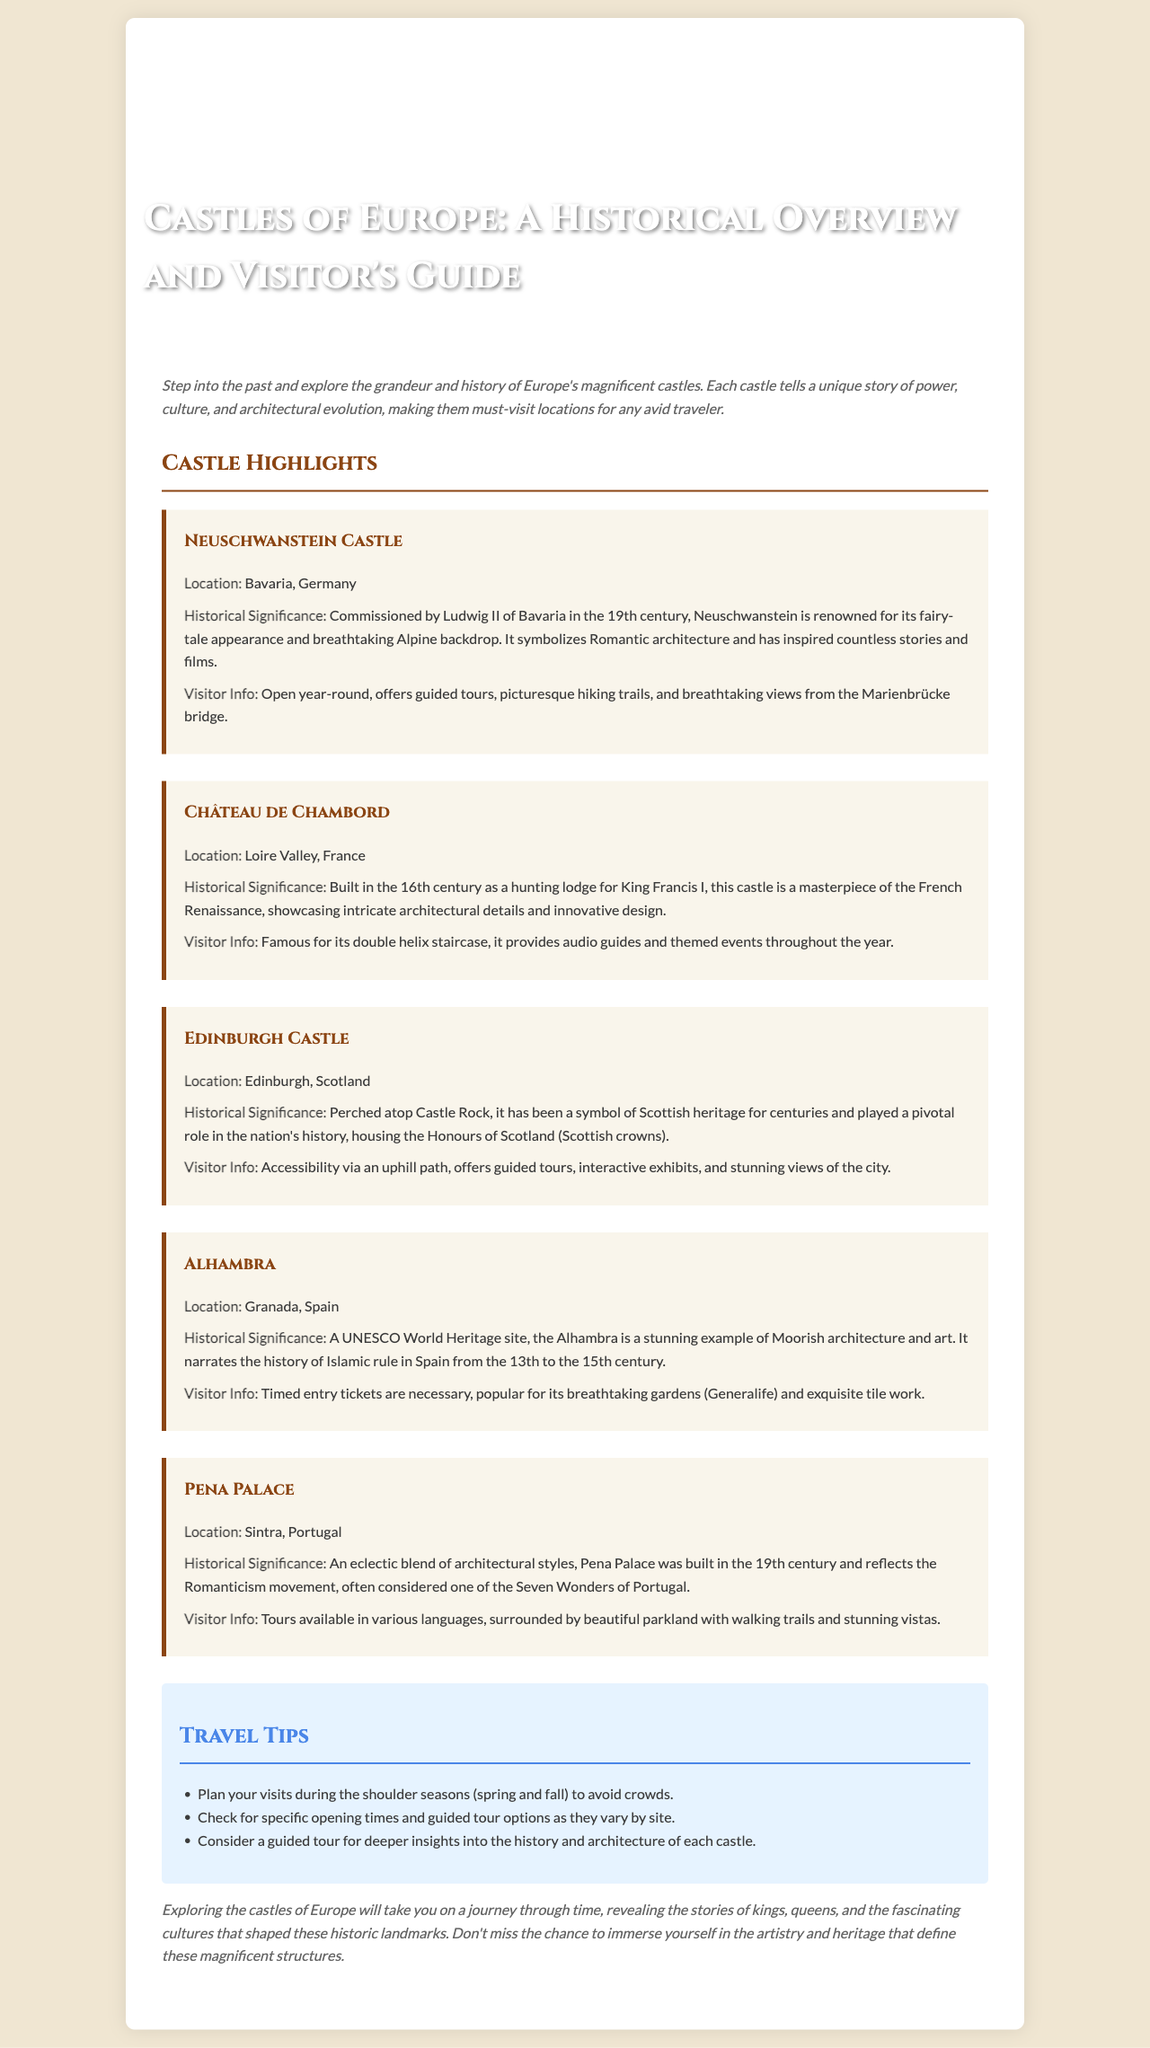What is the location of Neuschwanstein Castle? The document specifies that Neuschwanstein Castle is located in Bavaria, Germany.
Answer: Bavaria, Germany Who commissioned the Neuschwanstein Castle? The document mentions that Ludwig II of Bavaria commissioned Neuschwanstein Castle in the 19th century.
Answer: Ludwig II What architectural style is Château de Chambord known for? The document states that Château de Chambord is a masterpiece of the French Renaissance, showcasing intricate architectural details.
Answer: French Renaissance Which castle houses the Honours of Scotland? According to the document, Edinburgh Castle houses the Honours of Scotland.
Answer: Edinburgh Castle What historical period does the Alhambra represent? The document indicates that the Alhambra narrates the history of Islamic rule in Spain from the 13th to the 15th century.
Answer: 13th to the 15th century How many castles are highlighted in the document? The document lists five castles, each with their own section.
Answer: Five What type of tickets are needed for the Alhambra? The document mentions that timed entry tickets are necessary for visiting the Alhambra.
Answer: Timed entry tickets What is one travel tip mentioned in the document? The document suggests planning visits during the shoulder seasons (spring and fall) to avoid crowds.
Answer: Shoulder seasons What is the primary audience for this brochure? The document is tailored for avid travelers interested in historical and architectural landmarks in Europe.
Answer: Avid travelers 